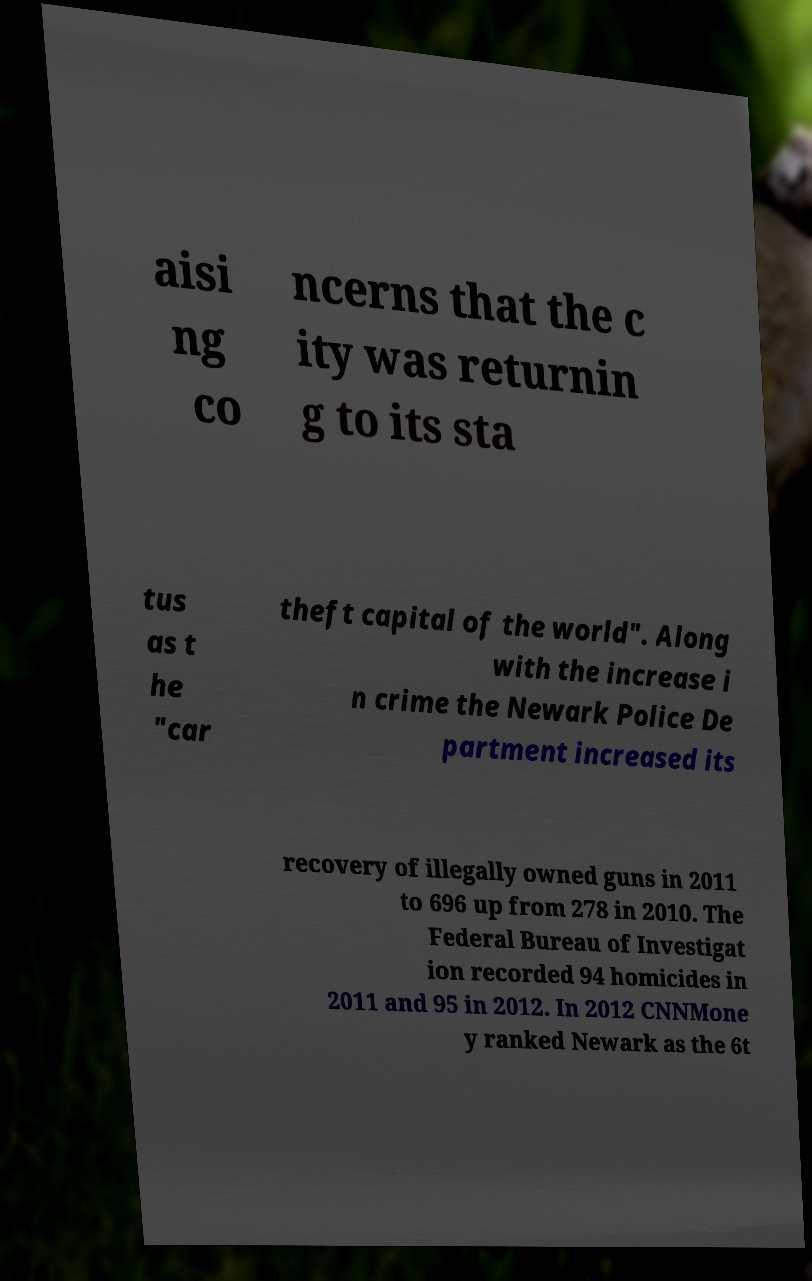Can you accurately transcribe the text from the provided image for me? aisi ng co ncerns that the c ity was returnin g to its sta tus as t he "car theft capital of the world". Along with the increase i n crime the Newark Police De partment increased its recovery of illegally owned guns in 2011 to 696 up from 278 in 2010. The Federal Bureau of Investigat ion recorded 94 homicides in 2011 and 95 in 2012. In 2012 CNNMone y ranked Newark as the 6t 